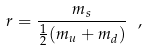Convert formula to latex. <formula><loc_0><loc_0><loc_500><loc_500>r = \frac { m _ { s } } { \frac { 1 } { 2 } ( m _ { u } + m _ { d } ) } \ ,</formula> 